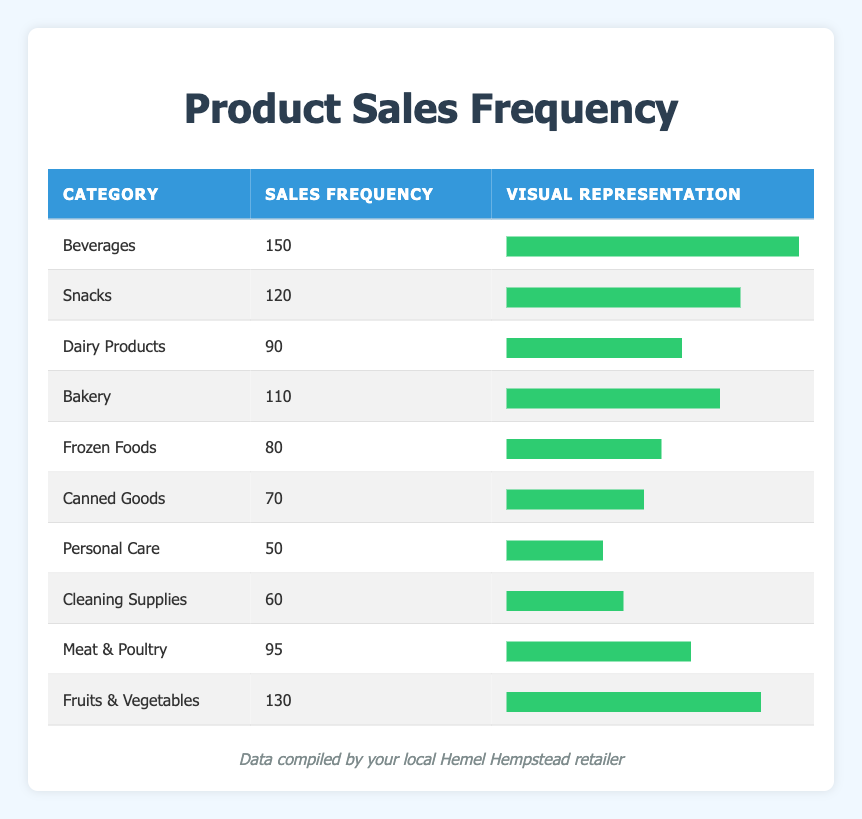What is the category with the highest sales frequency? By examining the sales frequency column, I see that "Beverages" has the highest value at 150, which is larger than all other categories.
Answer: Beverages How many sales frequency does the "Fruits & Vegetables" category have? The table explicitly shows that "Fruits & Vegetables" has a sales frequency of 130.
Answer: 130 Is the sales frequency of "Canned Goods" greater than 70? Looking at the table, "Canned Goods" has a sales frequency of 70, which means it is not greater than 70.
Answer: No What are the total sales frequencies for Dairy Products and Meat & Poultry combined? Adding the sales frequencies of Dairy Products (90) and Meat & Poultry (95) gives us 90 + 95 = 185.
Answer: 185 Which categories have a sales frequency greater than 100? I identify that "Beverages" (150), "Snacks" (120), "Fruits & Vegetables" (130), and "Bakery" (110) all have frequencies exceeding 100.
Answer: Beverages, Snacks, Fruits & Vegetables, Bakery What is the average sales frequency of all categories? To find the average, I sum all sales frequencies (150 + 120 + 90 + 110 + 80 + 70 + 50 + 60 + 95 + 130 = 1,005) and divide by the number of categories (10), which is 1,005 / 10 = 100.5.
Answer: 100.5 Are the sales frequencies of "Personal Care" and "Cleaning Supplies" both lower than 70? "Personal Care" has a frequency of 50 and "Cleaning Supplies" has 60, and both values are less than 70, confirming the statement as true.
Answer: Yes What is the difference in sales frequency between "Beverages" and "Frozen Foods"? The sales frequency for "Beverages" is 150 and for "Frozen Foods" it is 80. The difference is 150 - 80 = 70.
Answer: 70 Which category has a sales frequency closest to the median of all categories? To find the median, I first list the frequencies in ascending order: 50, 60, 70, 80, 90, 95, 110, 120, 130, 150. The median of this 10-item list is the average of the 5th (90) and 6th (95) values, which is (90 + 95) / 2 = 92.5. The closest value to this is "Meat & Poultry" with a frequency of 95.
Answer: Meat & Poultry 